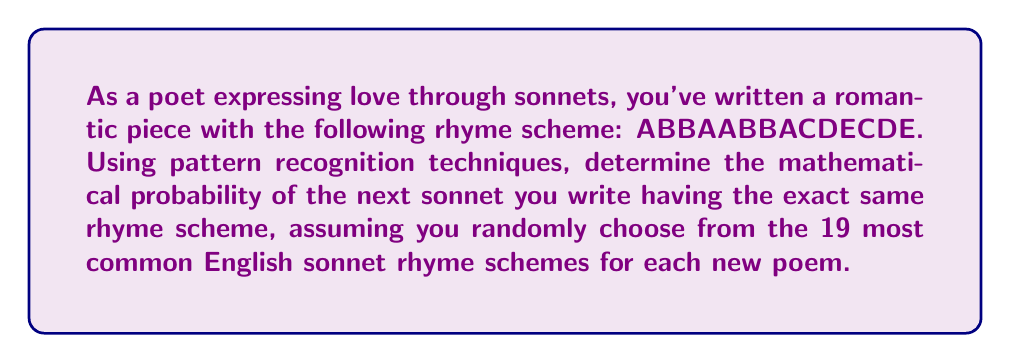What is the answer to this math problem? To solve this problem, we need to follow these steps:

1) First, we need to recognize that the given rhyme scheme (ABBAABBACDECDE) is known as the Petrarchan or Italian sonnet form.

2) The question states that there are 19 most common English sonnet rhyme schemes. This means that for each new sonnet, we have 19 possible choices.

3) The probability of an event occurring is calculated by dividing the number of favorable outcomes by the total number of possible outcomes:

   $$ P(\text{event}) = \frac{\text{number of favorable outcomes}}{\text{total number of possible outcomes}} $$

4) In this case:
   - The number of favorable outcomes is 1 (we want the exact same rhyme scheme)
   - The total number of possible outcomes is 19 (the number of common rhyme schemes)

5) Therefore, the probability is:

   $$ P(\text{same rhyme scheme}) = \frac{1}{19} $$

6) This can be expressed as a decimal by dividing:

   $$ \frac{1}{19} \approx 0.0526 $$

7) To express as a percentage, multiply by 100:

   $$ 0.0526 \times 100 \approx 5.26\% $$

Thus, there is approximately a 5.26% chance that the next sonnet will have the exact same rhyme scheme.
Answer: $\frac{1}{19}$ or approximately 5.26% 